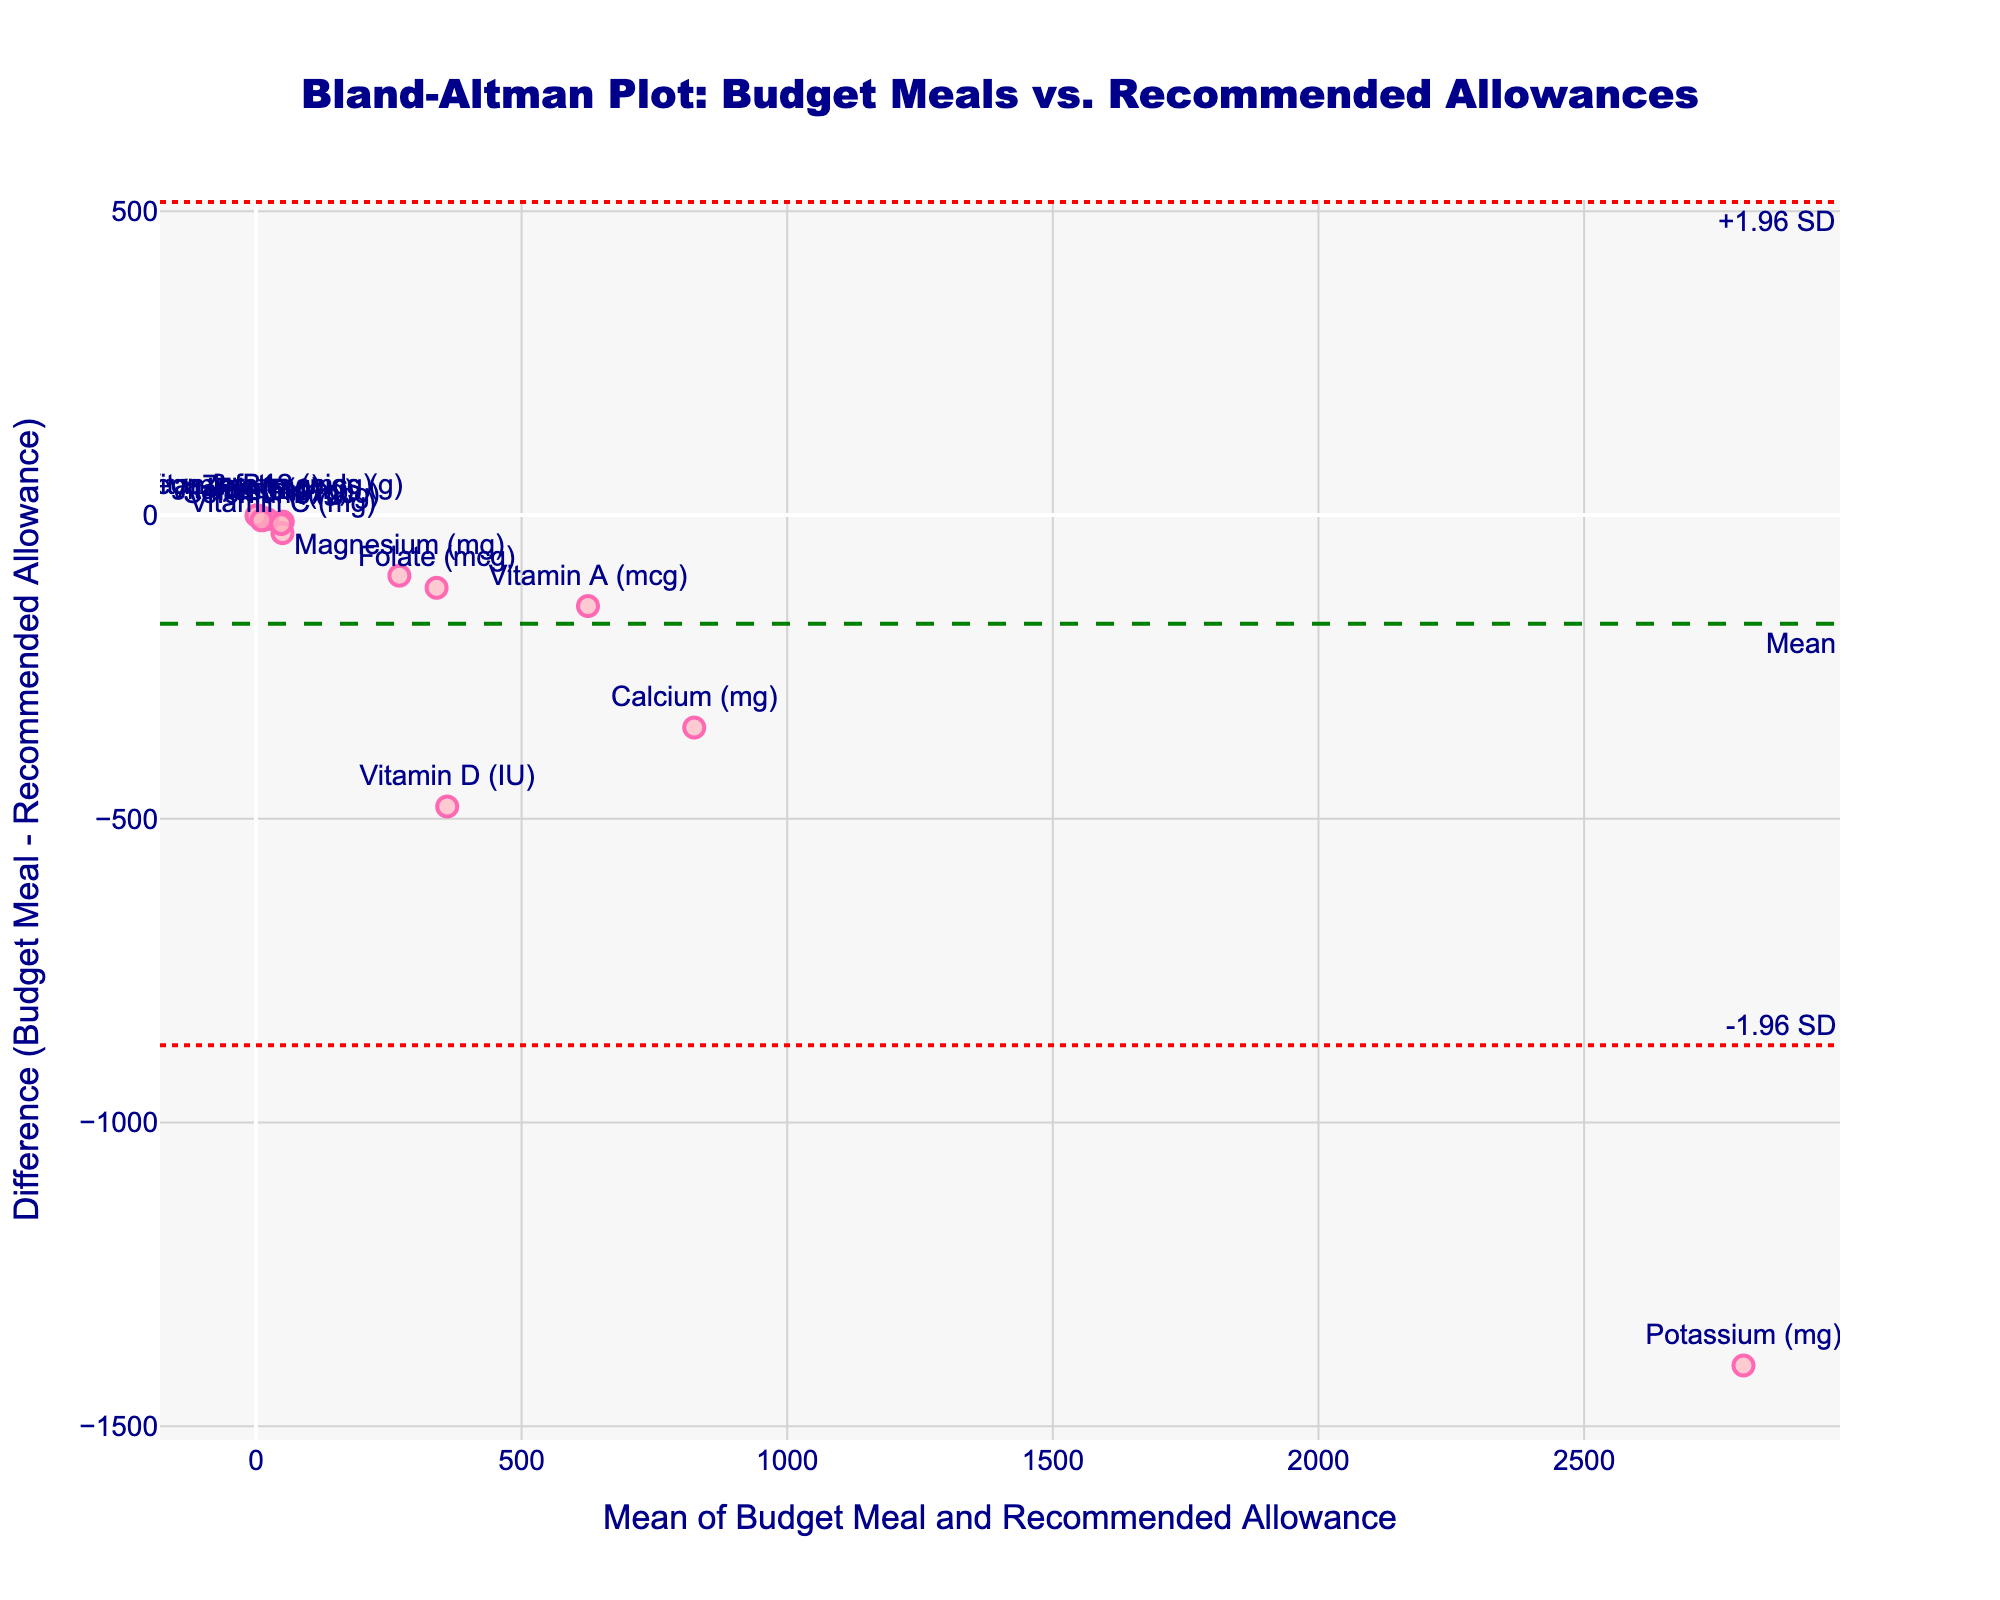What is the title of the plot? The title is located at the top of the plot and is center-aligned.
Answer: Bland-Altman Plot: Budget Meals vs. Recommended Allowances What does the x-axis represent in the plot? The x-axis title appears directly below the horizontal axis and describes what the axis measures.
Answer: Mean of Budget Meal and Recommended Allowance What is the highest nutrient difference shown in the plot? To find the highest nutrient difference, look at the highest point on the y-axis, which represents the nutrient with the largest positive or smallest negative difference between Budget Meals and Recommended Allowance.
Answer: Potassium (mg) How many data points are shown on the plot? Count the number of markers on the plot to determine the total number of data points.
Answer: 15 Which nutrient has the closest difference to zero? Identify the data point nearest to the horizontal axis, as it represents the smallest difference between Budget Meals and Recommended Allowance.
Answer: Zinc (mg) What are the mean and standard deviation of the nutrient differences? The mean difference is indicated by the green dashed line, and the standard deviation lines are dotted red lines, marked as +1.96 SD and -1.96 SD. Refer to the labels alongside these lines.
Answer: Mean diff: -222; Std diff: approximately 448 Which nutrient has the smallest mean value? Find the data point on the plot where the x-axis (average of Budget Meal and Recommended Allowance) is the smallest.
Answer: Vitamin B12 (mcg) What’s the difference between the nutrient with the highest mean value and the nutrient with the lowest mean value? Identify the highest mean (rightmost point) and the lowest mean (leftmost point) values on the x-axis. Subtract the lowest mean value from the highest mean value.
Answer: 2400 - 2.1 = 2397.9 Which nutrients fall outside the limits of agreement (-1.96 SD to +1.96 SD)? Locate data points that fall above the upper dotted red line or below the lower dotted red line on the y-axis, then identify their respective nutrients.
Answer: Potassium (mg) and Vitamin D (IU) How does the difference in Vitamin D compare to the mean difference? Compare the Vitamin D data point's position on the y-axis to the green mean difference line to see if it's above, below, or similar to the mean difference.
Answer: The difference in Vitamin D is much lower (more negative) than the mean difference 